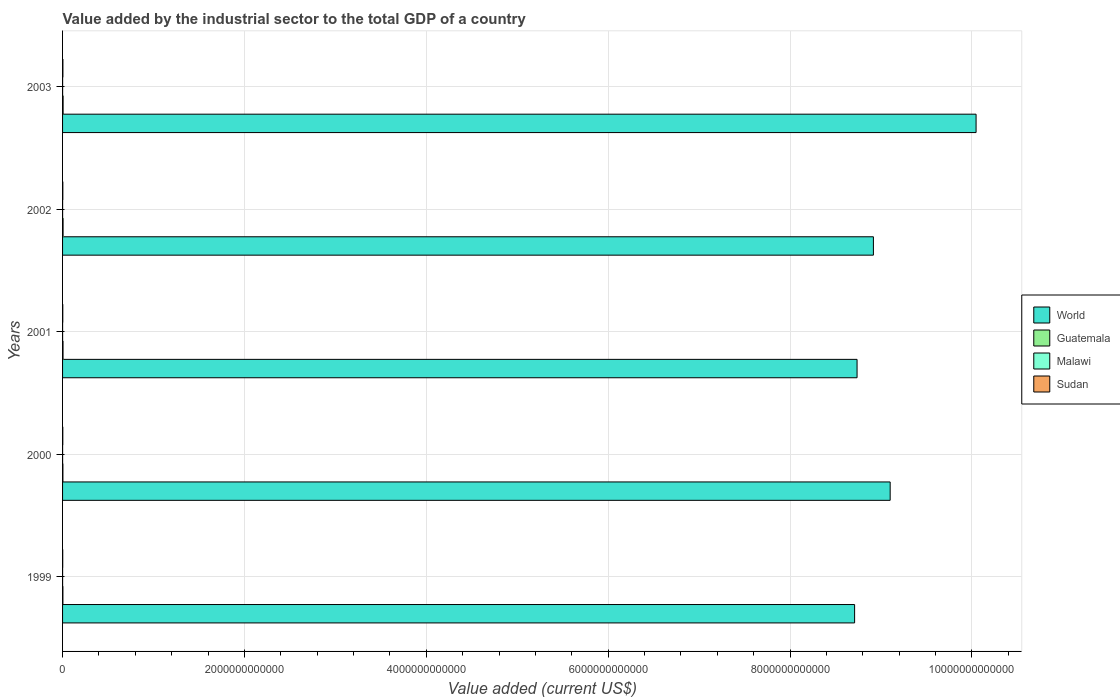How many groups of bars are there?
Your answer should be very brief. 5. Are the number of bars per tick equal to the number of legend labels?
Provide a succinct answer. Yes. In how many cases, is the number of bars for a given year not equal to the number of legend labels?
Make the answer very short. 0. What is the value added by the industrial sector to the total GDP in Guatemala in 2000?
Offer a terse response. 3.82e+09. Across all years, what is the maximum value added by the industrial sector to the total GDP in Malawi?
Your answer should be very brief. 4.34e+08. Across all years, what is the minimum value added by the industrial sector to the total GDP in Guatemala?
Provide a short and direct response. 3.69e+09. In which year was the value added by the industrial sector to the total GDP in World maximum?
Make the answer very short. 2003. What is the total value added by the industrial sector to the total GDP in World in the graph?
Give a very brief answer. 4.55e+13. What is the difference between the value added by the industrial sector to the total GDP in Sudan in 2000 and that in 2003?
Provide a short and direct response. -1.32e+09. What is the difference between the value added by the industrial sector to the total GDP in Guatemala in 2001 and the value added by the industrial sector to the total GDP in Sudan in 2003?
Make the answer very short. 1.26e+09. What is the average value added by the industrial sector to the total GDP in World per year?
Provide a short and direct response. 9.10e+12. In the year 1999, what is the difference between the value added by the industrial sector to the total GDP in Guatemala and value added by the industrial sector to the total GDP in Malawi?
Give a very brief answer. 3.39e+09. What is the ratio of the value added by the industrial sector to the total GDP in Malawi in 2001 to that in 2002?
Provide a short and direct response. 0.65. Is the value added by the industrial sector to the total GDP in Guatemala in 2001 less than that in 2003?
Provide a short and direct response. Yes. What is the difference between the highest and the second highest value added by the industrial sector to the total GDP in Sudan?
Keep it short and to the point. 8.58e+08. What is the difference between the highest and the lowest value added by the industrial sector to the total GDP in Sudan?
Your response must be concise. 2.12e+09. Is the sum of the value added by the industrial sector to the total GDP in Sudan in 2000 and 2002 greater than the maximum value added by the industrial sector to the total GDP in Malawi across all years?
Your answer should be very brief. Yes. What does the 3rd bar from the top in 2001 represents?
Offer a very short reply. Guatemala. What does the 1st bar from the bottom in 2003 represents?
Provide a succinct answer. World. Is it the case that in every year, the sum of the value added by the industrial sector to the total GDP in Sudan and value added by the industrial sector to the total GDP in Malawi is greater than the value added by the industrial sector to the total GDP in Guatemala?
Provide a succinct answer. No. How many bars are there?
Offer a very short reply. 20. Are all the bars in the graph horizontal?
Make the answer very short. Yes. What is the difference between two consecutive major ticks on the X-axis?
Offer a very short reply. 2.00e+12. Does the graph contain any zero values?
Offer a terse response. No. Does the graph contain grids?
Your answer should be very brief. Yes. Where does the legend appear in the graph?
Your response must be concise. Center right. How many legend labels are there?
Provide a succinct answer. 4. What is the title of the graph?
Your response must be concise. Value added by the industrial sector to the total GDP of a country. What is the label or title of the X-axis?
Offer a terse response. Value added (current US$). What is the Value added (current US$) of World in 1999?
Offer a terse response. 8.71e+12. What is the Value added (current US$) of Guatemala in 1999?
Offer a very short reply. 3.69e+09. What is the Value added (current US$) in Malawi in 1999?
Your response must be concise. 2.94e+08. What is the Value added (current US$) in Sudan in 1999?
Make the answer very short. 1.66e+09. What is the Value added (current US$) in World in 2000?
Offer a very short reply. 9.10e+12. What is the Value added (current US$) in Guatemala in 2000?
Offer a terse response. 3.82e+09. What is the Value added (current US$) of Malawi in 2000?
Provide a short and direct response. 2.82e+08. What is the Value added (current US$) in Sudan in 2000?
Provide a succinct answer. 2.46e+09. What is the Value added (current US$) of World in 2001?
Keep it short and to the point. 8.74e+12. What is the Value added (current US$) in Guatemala in 2001?
Offer a terse response. 5.03e+09. What is the Value added (current US$) of Malawi in 2001?
Offer a terse response. 2.61e+08. What is the Value added (current US$) of Sudan in 2001?
Ensure brevity in your answer.  2.37e+09. What is the Value added (current US$) in World in 2002?
Give a very brief answer. 8.92e+12. What is the Value added (current US$) of Guatemala in 2002?
Your answer should be compact. 5.56e+09. What is the Value added (current US$) in Malawi in 2002?
Your answer should be compact. 3.98e+08. What is the Value added (current US$) of Sudan in 2002?
Give a very brief answer. 2.92e+09. What is the Value added (current US$) of World in 2003?
Provide a succinct answer. 1.00e+13. What is the Value added (current US$) of Guatemala in 2003?
Give a very brief answer. 5.92e+09. What is the Value added (current US$) in Malawi in 2003?
Offer a terse response. 4.34e+08. What is the Value added (current US$) of Sudan in 2003?
Provide a succinct answer. 3.78e+09. Across all years, what is the maximum Value added (current US$) of World?
Your answer should be very brief. 1.00e+13. Across all years, what is the maximum Value added (current US$) of Guatemala?
Keep it short and to the point. 5.92e+09. Across all years, what is the maximum Value added (current US$) of Malawi?
Offer a terse response. 4.34e+08. Across all years, what is the maximum Value added (current US$) in Sudan?
Make the answer very short. 3.78e+09. Across all years, what is the minimum Value added (current US$) in World?
Ensure brevity in your answer.  8.71e+12. Across all years, what is the minimum Value added (current US$) in Guatemala?
Your answer should be compact. 3.69e+09. Across all years, what is the minimum Value added (current US$) in Malawi?
Your answer should be very brief. 2.61e+08. Across all years, what is the minimum Value added (current US$) of Sudan?
Offer a terse response. 1.66e+09. What is the total Value added (current US$) in World in the graph?
Your answer should be compact. 4.55e+13. What is the total Value added (current US$) of Guatemala in the graph?
Provide a short and direct response. 2.40e+1. What is the total Value added (current US$) of Malawi in the graph?
Offer a very short reply. 1.67e+09. What is the total Value added (current US$) of Sudan in the graph?
Make the answer very short. 1.32e+1. What is the difference between the Value added (current US$) in World in 1999 and that in 2000?
Give a very brief answer. -3.91e+11. What is the difference between the Value added (current US$) in Guatemala in 1999 and that in 2000?
Offer a terse response. -1.32e+08. What is the difference between the Value added (current US$) in Malawi in 1999 and that in 2000?
Offer a very short reply. 1.26e+07. What is the difference between the Value added (current US$) in Sudan in 1999 and that in 2000?
Provide a succinct answer. -8.02e+08. What is the difference between the Value added (current US$) of World in 1999 and that in 2001?
Provide a short and direct response. -2.71e+1. What is the difference between the Value added (current US$) of Guatemala in 1999 and that in 2001?
Give a very brief answer. -1.35e+09. What is the difference between the Value added (current US$) in Malawi in 1999 and that in 2001?
Ensure brevity in your answer.  3.38e+07. What is the difference between the Value added (current US$) in Sudan in 1999 and that in 2001?
Your answer should be compact. -7.15e+08. What is the difference between the Value added (current US$) of World in 1999 and that in 2002?
Make the answer very short. -2.07e+11. What is the difference between the Value added (current US$) in Guatemala in 1999 and that in 2002?
Offer a terse response. -1.87e+09. What is the difference between the Value added (current US$) in Malawi in 1999 and that in 2002?
Provide a short and direct response. -1.04e+08. What is the difference between the Value added (current US$) of Sudan in 1999 and that in 2002?
Give a very brief answer. -1.26e+09. What is the difference between the Value added (current US$) of World in 1999 and that in 2003?
Keep it short and to the point. -1.34e+12. What is the difference between the Value added (current US$) in Guatemala in 1999 and that in 2003?
Keep it short and to the point. -2.24e+09. What is the difference between the Value added (current US$) in Malawi in 1999 and that in 2003?
Your answer should be very brief. -1.39e+08. What is the difference between the Value added (current US$) of Sudan in 1999 and that in 2003?
Ensure brevity in your answer.  -2.12e+09. What is the difference between the Value added (current US$) of World in 2000 and that in 2001?
Provide a succinct answer. 3.64e+11. What is the difference between the Value added (current US$) of Guatemala in 2000 and that in 2001?
Offer a terse response. -1.21e+09. What is the difference between the Value added (current US$) of Malawi in 2000 and that in 2001?
Ensure brevity in your answer.  2.11e+07. What is the difference between the Value added (current US$) in Sudan in 2000 and that in 2001?
Your answer should be compact. 8.71e+07. What is the difference between the Value added (current US$) of World in 2000 and that in 2002?
Offer a terse response. 1.84e+11. What is the difference between the Value added (current US$) in Guatemala in 2000 and that in 2002?
Your answer should be compact. -1.74e+09. What is the difference between the Value added (current US$) in Malawi in 2000 and that in 2002?
Offer a very short reply. -1.16e+08. What is the difference between the Value added (current US$) of Sudan in 2000 and that in 2002?
Offer a very short reply. -4.57e+08. What is the difference between the Value added (current US$) in World in 2000 and that in 2003?
Offer a very short reply. -9.45e+11. What is the difference between the Value added (current US$) of Guatemala in 2000 and that in 2003?
Your answer should be very brief. -2.10e+09. What is the difference between the Value added (current US$) in Malawi in 2000 and that in 2003?
Your answer should be compact. -1.52e+08. What is the difference between the Value added (current US$) in Sudan in 2000 and that in 2003?
Your answer should be compact. -1.32e+09. What is the difference between the Value added (current US$) in World in 2001 and that in 2002?
Make the answer very short. -1.80e+11. What is the difference between the Value added (current US$) in Guatemala in 2001 and that in 2002?
Your response must be concise. -5.25e+08. What is the difference between the Value added (current US$) in Malawi in 2001 and that in 2002?
Provide a short and direct response. -1.37e+08. What is the difference between the Value added (current US$) of Sudan in 2001 and that in 2002?
Ensure brevity in your answer.  -5.44e+08. What is the difference between the Value added (current US$) of World in 2001 and that in 2003?
Make the answer very short. -1.31e+12. What is the difference between the Value added (current US$) in Guatemala in 2001 and that in 2003?
Your answer should be compact. -8.89e+08. What is the difference between the Value added (current US$) of Malawi in 2001 and that in 2003?
Provide a short and direct response. -1.73e+08. What is the difference between the Value added (current US$) in Sudan in 2001 and that in 2003?
Ensure brevity in your answer.  -1.40e+09. What is the difference between the Value added (current US$) of World in 2002 and that in 2003?
Provide a short and direct response. -1.13e+12. What is the difference between the Value added (current US$) in Guatemala in 2002 and that in 2003?
Give a very brief answer. -3.64e+08. What is the difference between the Value added (current US$) in Malawi in 2002 and that in 2003?
Provide a short and direct response. -3.58e+07. What is the difference between the Value added (current US$) of Sudan in 2002 and that in 2003?
Your answer should be compact. -8.58e+08. What is the difference between the Value added (current US$) in World in 1999 and the Value added (current US$) in Guatemala in 2000?
Keep it short and to the point. 8.71e+12. What is the difference between the Value added (current US$) in World in 1999 and the Value added (current US$) in Malawi in 2000?
Provide a short and direct response. 8.71e+12. What is the difference between the Value added (current US$) of World in 1999 and the Value added (current US$) of Sudan in 2000?
Offer a very short reply. 8.71e+12. What is the difference between the Value added (current US$) of Guatemala in 1999 and the Value added (current US$) of Malawi in 2000?
Your response must be concise. 3.40e+09. What is the difference between the Value added (current US$) in Guatemala in 1999 and the Value added (current US$) in Sudan in 2000?
Offer a terse response. 1.22e+09. What is the difference between the Value added (current US$) of Malawi in 1999 and the Value added (current US$) of Sudan in 2000?
Your answer should be compact. -2.17e+09. What is the difference between the Value added (current US$) of World in 1999 and the Value added (current US$) of Guatemala in 2001?
Give a very brief answer. 8.71e+12. What is the difference between the Value added (current US$) of World in 1999 and the Value added (current US$) of Malawi in 2001?
Ensure brevity in your answer.  8.71e+12. What is the difference between the Value added (current US$) of World in 1999 and the Value added (current US$) of Sudan in 2001?
Give a very brief answer. 8.71e+12. What is the difference between the Value added (current US$) in Guatemala in 1999 and the Value added (current US$) in Malawi in 2001?
Give a very brief answer. 3.42e+09. What is the difference between the Value added (current US$) in Guatemala in 1999 and the Value added (current US$) in Sudan in 2001?
Your response must be concise. 1.31e+09. What is the difference between the Value added (current US$) of Malawi in 1999 and the Value added (current US$) of Sudan in 2001?
Provide a succinct answer. -2.08e+09. What is the difference between the Value added (current US$) in World in 1999 and the Value added (current US$) in Guatemala in 2002?
Keep it short and to the point. 8.70e+12. What is the difference between the Value added (current US$) in World in 1999 and the Value added (current US$) in Malawi in 2002?
Provide a short and direct response. 8.71e+12. What is the difference between the Value added (current US$) of World in 1999 and the Value added (current US$) of Sudan in 2002?
Offer a very short reply. 8.71e+12. What is the difference between the Value added (current US$) of Guatemala in 1999 and the Value added (current US$) of Malawi in 2002?
Your answer should be compact. 3.29e+09. What is the difference between the Value added (current US$) in Guatemala in 1999 and the Value added (current US$) in Sudan in 2002?
Make the answer very short. 7.67e+08. What is the difference between the Value added (current US$) in Malawi in 1999 and the Value added (current US$) in Sudan in 2002?
Provide a short and direct response. -2.62e+09. What is the difference between the Value added (current US$) in World in 1999 and the Value added (current US$) in Guatemala in 2003?
Your response must be concise. 8.70e+12. What is the difference between the Value added (current US$) of World in 1999 and the Value added (current US$) of Malawi in 2003?
Make the answer very short. 8.71e+12. What is the difference between the Value added (current US$) of World in 1999 and the Value added (current US$) of Sudan in 2003?
Offer a terse response. 8.71e+12. What is the difference between the Value added (current US$) of Guatemala in 1999 and the Value added (current US$) of Malawi in 2003?
Provide a short and direct response. 3.25e+09. What is the difference between the Value added (current US$) of Guatemala in 1999 and the Value added (current US$) of Sudan in 2003?
Your response must be concise. -9.13e+07. What is the difference between the Value added (current US$) in Malawi in 1999 and the Value added (current US$) in Sudan in 2003?
Ensure brevity in your answer.  -3.48e+09. What is the difference between the Value added (current US$) of World in 2000 and the Value added (current US$) of Guatemala in 2001?
Provide a succinct answer. 9.10e+12. What is the difference between the Value added (current US$) of World in 2000 and the Value added (current US$) of Malawi in 2001?
Provide a succinct answer. 9.10e+12. What is the difference between the Value added (current US$) in World in 2000 and the Value added (current US$) in Sudan in 2001?
Your response must be concise. 9.10e+12. What is the difference between the Value added (current US$) in Guatemala in 2000 and the Value added (current US$) in Malawi in 2001?
Provide a succinct answer. 3.56e+09. What is the difference between the Value added (current US$) of Guatemala in 2000 and the Value added (current US$) of Sudan in 2001?
Keep it short and to the point. 1.44e+09. What is the difference between the Value added (current US$) in Malawi in 2000 and the Value added (current US$) in Sudan in 2001?
Provide a short and direct response. -2.09e+09. What is the difference between the Value added (current US$) of World in 2000 and the Value added (current US$) of Guatemala in 2002?
Offer a terse response. 9.10e+12. What is the difference between the Value added (current US$) in World in 2000 and the Value added (current US$) in Malawi in 2002?
Provide a succinct answer. 9.10e+12. What is the difference between the Value added (current US$) of World in 2000 and the Value added (current US$) of Sudan in 2002?
Ensure brevity in your answer.  9.10e+12. What is the difference between the Value added (current US$) of Guatemala in 2000 and the Value added (current US$) of Malawi in 2002?
Provide a succinct answer. 3.42e+09. What is the difference between the Value added (current US$) of Guatemala in 2000 and the Value added (current US$) of Sudan in 2002?
Your answer should be compact. 8.99e+08. What is the difference between the Value added (current US$) in Malawi in 2000 and the Value added (current US$) in Sudan in 2002?
Your answer should be compact. -2.64e+09. What is the difference between the Value added (current US$) in World in 2000 and the Value added (current US$) in Guatemala in 2003?
Your answer should be compact. 9.10e+12. What is the difference between the Value added (current US$) in World in 2000 and the Value added (current US$) in Malawi in 2003?
Give a very brief answer. 9.10e+12. What is the difference between the Value added (current US$) in World in 2000 and the Value added (current US$) in Sudan in 2003?
Your answer should be compact. 9.10e+12. What is the difference between the Value added (current US$) of Guatemala in 2000 and the Value added (current US$) of Malawi in 2003?
Offer a very short reply. 3.38e+09. What is the difference between the Value added (current US$) of Guatemala in 2000 and the Value added (current US$) of Sudan in 2003?
Ensure brevity in your answer.  4.12e+07. What is the difference between the Value added (current US$) in Malawi in 2000 and the Value added (current US$) in Sudan in 2003?
Your response must be concise. -3.49e+09. What is the difference between the Value added (current US$) in World in 2001 and the Value added (current US$) in Guatemala in 2002?
Your answer should be compact. 8.73e+12. What is the difference between the Value added (current US$) of World in 2001 and the Value added (current US$) of Malawi in 2002?
Your response must be concise. 8.74e+12. What is the difference between the Value added (current US$) of World in 2001 and the Value added (current US$) of Sudan in 2002?
Ensure brevity in your answer.  8.73e+12. What is the difference between the Value added (current US$) in Guatemala in 2001 and the Value added (current US$) in Malawi in 2002?
Your response must be concise. 4.63e+09. What is the difference between the Value added (current US$) of Guatemala in 2001 and the Value added (current US$) of Sudan in 2002?
Make the answer very short. 2.11e+09. What is the difference between the Value added (current US$) of Malawi in 2001 and the Value added (current US$) of Sudan in 2002?
Make the answer very short. -2.66e+09. What is the difference between the Value added (current US$) of World in 2001 and the Value added (current US$) of Guatemala in 2003?
Provide a short and direct response. 8.73e+12. What is the difference between the Value added (current US$) in World in 2001 and the Value added (current US$) in Malawi in 2003?
Offer a very short reply. 8.74e+12. What is the difference between the Value added (current US$) in World in 2001 and the Value added (current US$) in Sudan in 2003?
Offer a very short reply. 8.73e+12. What is the difference between the Value added (current US$) of Guatemala in 2001 and the Value added (current US$) of Malawi in 2003?
Provide a short and direct response. 4.60e+09. What is the difference between the Value added (current US$) in Guatemala in 2001 and the Value added (current US$) in Sudan in 2003?
Give a very brief answer. 1.26e+09. What is the difference between the Value added (current US$) of Malawi in 2001 and the Value added (current US$) of Sudan in 2003?
Keep it short and to the point. -3.52e+09. What is the difference between the Value added (current US$) of World in 2002 and the Value added (current US$) of Guatemala in 2003?
Offer a very short reply. 8.91e+12. What is the difference between the Value added (current US$) of World in 2002 and the Value added (current US$) of Malawi in 2003?
Make the answer very short. 8.92e+12. What is the difference between the Value added (current US$) of World in 2002 and the Value added (current US$) of Sudan in 2003?
Make the answer very short. 8.91e+12. What is the difference between the Value added (current US$) in Guatemala in 2002 and the Value added (current US$) in Malawi in 2003?
Your response must be concise. 5.12e+09. What is the difference between the Value added (current US$) in Guatemala in 2002 and the Value added (current US$) in Sudan in 2003?
Your response must be concise. 1.78e+09. What is the difference between the Value added (current US$) of Malawi in 2002 and the Value added (current US$) of Sudan in 2003?
Your answer should be compact. -3.38e+09. What is the average Value added (current US$) in World per year?
Make the answer very short. 9.10e+12. What is the average Value added (current US$) of Guatemala per year?
Provide a succinct answer. 4.80e+09. What is the average Value added (current US$) of Malawi per year?
Offer a very short reply. 3.34e+08. What is the average Value added (current US$) of Sudan per year?
Make the answer very short. 2.64e+09. In the year 1999, what is the difference between the Value added (current US$) of World and Value added (current US$) of Guatemala?
Make the answer very short. 8.71e+12. In the year 1999, what is the difference between the Value added (current US$) of World and Value added (current US$) of Malawi?
Your answer should be very brief. 8.71e+12. In the year 1999, what is the difference between the Value added (current US$) of World and Value added (current US$) of Sudan?
Provide a succinct answer. 8.71e+12. In the year 1999, what is the difference between the Value added (current US$) of Guatemala and Value added (current US$) of Malawi?
Make the answer very short. 3.39e+09. In the year 1999, what is the difference between the Value added (current US$) of Guatemala and Value added (current US$) of Sudan?
Offer a very short reply. 2.03e+09. In the year 1999, what is the difference between the Value added (current US$) in Malawi and Value added (current US$) in Sudan?
Ensure brevity in your answer.  -1.36e+09. In the year 2000, what is the difference between the Value added (current US$) in World and Value added (current US$) in Guatemala?
Your answer should be very brief. 9.10e+12. In the year 2000, what is the difference between the Value added (current US$) of World and Value added (current US$) of Malawi?
Make the answer very short. 9.10e+12. In the year 2000, what is the difference between the Value added (current US$) of World and Value added (current US$) of Sudan?
Your answer should be compact. 9.10e+12. In the year 2000, what is the difference between the Value added (current US$) in Guatemala and Value added (current US$) in Malawi?
Your answer should be very brief. 3.54e+09. In the year 2000, what is the difference between the Value added (current US$) in Guatemala and Value added (current US$) in Sudan?
Offer a very short reply. 1.36e+09. In the year 2000, what is the difference between the Value added (current US$) of Malawi and Value added (current US$) of Sudan?
Make the answer very short. -2.18e+09. In the year 2001, what is the difference between the Value added (current US$) of World and Value added (current US$) of Guatemala?
Ensure brevity in your answer.  8.73e+12. In the year 2001, what is the difference between the Value added (current US$) of World and Value added (current US$) of Malawi?
Your answer should be compact. 8.74e+12. In the year 2001, what is the difference between the Value added (current US$) of World and Value added (current US$) of Sudan?
Your response must be concise. 8.73e+12. In the year 2001, what is the difference between the Value added (current US$) of Guatemala and Value added (current US$) of Malawi?
Your response must be concise. 4.77e+09. In the year 2001, what is the difference between the Value added (current US$) in Guatemala and Value added (current US$) in Sudan?
Offer a terse response. 2.66e+09. In the year 2001, what is the difference between the Value added (current US$) of Malawi and Value added (current US$) of Sudan?
Provide a short and direct response. -2.11e+09. In the year 2002, what is the difference between the Value added (current US$) of World and Value added (current US$) of Guatemala?
Keep it short and to the point. 8.91e+12. In the year 2002, what is the difference between the Value added (current US$) in World and Value added (current US$) in Malawi?
Give a very brief answer. 8.92e+12. In the year 2002, what is the difference between the Value added (current US$) of World and Value added (current US$) of Sudan?
Your response must be concise. 8.91e+12. In the year 2002, what is the difference between the Value added (current US$) in Guatemala and Value added (current US$) in Malawi?
Offer a terse response. 5.16e+09. In the year 2002, what is the difference between the Value added (current US$) in Guatemala and Value added (current US$) in Sudan?
Your response must be concise. 2.64e+09. In the year 2002, what is the difference between the Value added (current US$) in Malawi and Value added (current US$) in Sudan?
Your response must be concise. -2.52e+09. In the year 2003, what is the difference between the Value added (current US$) in World and Value added (current US$) in Guatemala?
Give a very brief answer. 1.00e+13. In the year 2003, what is the difference between the Value added (current US$) in World and Value added (current US$) in Malawi?
Give a very brief answer. 1.00e+13. In the year 2003, what is the difference between the Value added (current US$) in World and Value added (current US$) in Sudan?
Your answer should be very brief. 1.00e+13. In the year 2003, what is the difference between the Value added (current US$) in Guatemala and Value added (current US$) in Malawi?
Your answer should be very brief. 5.49e+09. In the year 2003, what is the difference between the Value added (current US$) of Guatemala and Value added (current US$) of Sudan?
Make the answer very short. 2.14e+09. In the year 2003, what is the difference between the Value added (current US$) of Malawi and Value added (current US$) of Sudan?
Keep it short and to the point. -3.34e+09. What is the ratio of the Value added (current US$) in World in 1999 to that in 2000?
Ensure brevity in your answer.  0.96. What is the ratio of the Value added (current US$) of Guatemala in 1999 to that in 2000?
Your response must be concise. 0.97. What is the ratio of the Value added (current US$) of Malawi in 1999 to that in 2000?
Keep it short and to the point. 1.04. What is the ratio of the Value added (current US$) in Sudan in 1999 to that in 2000?
Make the answer very short. 0.67. What is the ratio of the Value added (current US$) of World in 1999 to that in 2001?
Give a very brief answer. 1. What is the ratio of the Value added (current US$) of Guatemala in 1999 to that in 2001?
Give a very brief answer. 0.73. What is the ratio of the Value added (current US$) in Malawi in 1999 to that in 2001?
Ensure brevity in your answer.  1.13. What is the ratio of the Value added (current US$) of Sudan in 1999 to that in 2001?
Ensure brevity in your answer.  0.7. What is the ratio of the Value added (current US$) of World in 1999 to that in 2002?
Keep it short and to the point. 0.98. What is the ratio of the Value added (current US$) of Guatemala in 1999 to that in 2002?
Your response must be concise. 0.66. What is the ratio of the Value added (current US$) of Malawi in 1999 to that in 2002?
Your response must be concise. 0.74. What is the ratio of the Value added (current US$) in Sudan in 1999 to that in 2002?
Keep it short and to the point. 0.57. What is the ratio of the Value added (current US$) of World in 1999 to that in 2003?
Your answer should be very brief. 0.87. What is the ratio of the Value added (current US$) of Guatemala in 1999 to that in 2003?
Your answer should be compact. 0.62. What is the ratio of the Value added (current US$) in Malawi in 1999 to that in 2003?
Offer a terse response. 0.68. What is the ratio of the Value added (current US$) of Sudan in 1999 to that in 2003?
Offer a very short reply. 0.44. What is the ratio of the Value added (current US$) of World in 2000 to that in 2001?
Your response must be concise. 1.04. What is the ratio of the Value added (current US$) in Guatemala in 2000 to that in 2001?
Provide a short and direct response. 0.76. What is the ratio of the Value added (current US$) of Malawi in 2000 to that in 2001?
Make the answer very short. 1.08. What is the ratio of the Value added (current US$) in Sudan in 2000 to that in 2001?
Make the answer very short. 1.04. What is the ratio of the Value added (current US$) of World in 2000 to that in 2002?
Your answer should be very brief. 1.02. What is the ratio of the Value added (current US$) in Guatemala in 2000 to that in 2002?
Give a very brief answer. 0.69. What is the ratio of the Value added (current US$) of Malawi in 2000 to that in 2002?
Keep it short and to the point. 0.71. What is the ratio of the Value added (current US$) of Sudan in 2000 to that in 2002?
Keep it short and to the point. 0.84. What is the ratio of the Value added (current US$) of World in 2000 to that in 2003?
Your response must be concise. 0.91. What is the ratio of the Value added (current US$) in Guatemala in 2000 to that in 2003?
Provide a succinct answer. 0.64. What is the ratio of the Value added (current US$) in Malawi in 2000 to that in 2003?
Your answer should be compact. 0.65. What is the ratio of the Value added (current US$) in Sudan in 2000 to that in 2003?
Your answer should be compact. 0.65. What is the ratio of the Value added (current US$) of World in 2001 to that in 2002?
Offer a very short reply. 0.98. What is the ratio of the Value added (current US$) in Guatemala in 2001 to that in 2002?
Ensure brevity in your answer.  0.91. What is the ratio of the Value added (current US$) of Malawi in 2001 to that in 2002?
Your answer should be very brief. 0.65. What is the ratio of the Value added (current US$) in Sudan in 2001 to that in 2002?
Your response must be concise. 0.81. What is the ratio of the Value added (current US$) of World in 2001 to that in 2003?
Provide a succinct answer. 0.87. What is the ratio of the Value added (current US$) of Guatemala in 2001 to that in 2003?
Offer a terse response. 0.85. What is the ratio of the Value added (current US$) of Malawi in 2001 to that in 2003?
Provide a short and direct response. 0.6. What is the ratio of the Value added (current US$) of Sudan in 2001 to that in 2003?
Give a very brief answer. 0.63. What is the ratio of the Value added (current US$) in World in 2002 to that in 2003?
Provide a succinct answer. 0.89. What is the ratio of the Value added (current US$) in Guatemala in 2002 to that in 2003?
Offer a terse response. 0.94. What is the ratio of the Value added (current US$) of Malawi in 2002 to that in 2003?
Your answer should be very brief. 0.92. What is the ratio of the Value added (current US$) of Sudan in 2002 to that in 2003?
Offer a terse response. 0.77. What is the difference between the highest and the second highest Value added (current US$) in World?
Your answer should be very brief. 9.45e+11. What is the difference between the highest and the second highest Value added (current US$) of Guatemala?
Your response must be concise. 3.64e+08. What is the difference between the highest and the second highest Value added (current US$) in Malawi?
Offer a terse response. 3.58e+07. What is the difference between the highest and the second highest Value added (current US$) in Sudan?
Keep it short and to the point. 8.58e+08. What is the difference between the highest and the lowest Value added (current US$) of World?
Your response must be concise. 1.34e+12. What is the difference between the highest and the lowest Value added (current US$) in Guatemala?
Offer a terse response. 2.24e+09. What is the difference between the highest and the lowest Value added (current US$) of Malawi?
Ensure brevity in your answer.  1.73e+08. What is the difference between the highest and the lowest Value added (current US$) of Sudan?
Keep it short and to the point. 2.12e+09. 